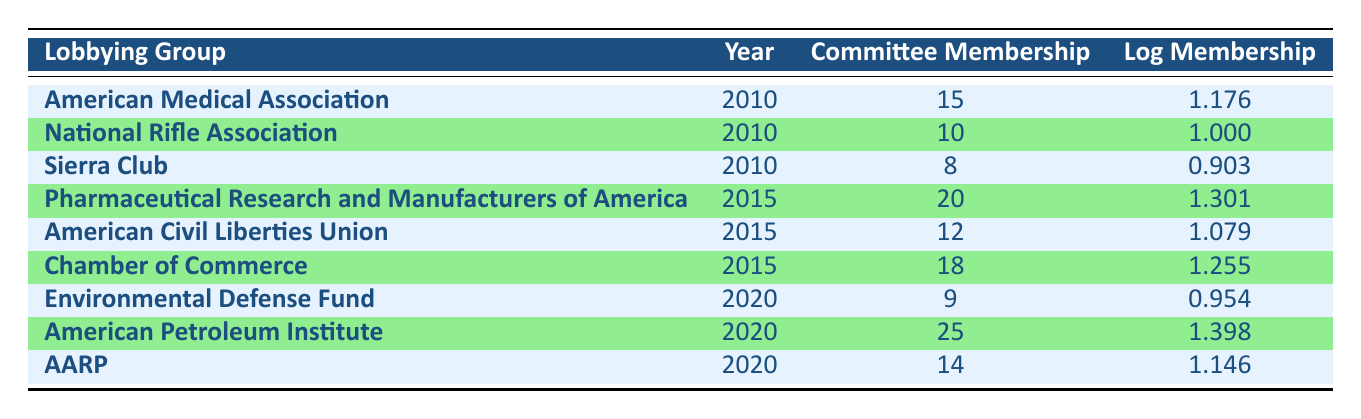What was the committee membership for the American Medical Association in 2010? The table shows that the American Medical Association had a committee membership of 15 in 2010, which is specified in the row corresponding to that organization and year.
Answer: 15 What is the log membership value for the National Rifle Association in 2010? According to the table, the log membership value for the National Rifle Association in 2010 is 1.000, as indicated in the relevant row.
Answer: 1.000 Which lobbying group had the highest committee membership in 2020? Looking at the table for the year 2020, the American Petroleum Institute had the highest committee membership at 25, compared to the other organizations listed for that year.
Answer: American Petroleum Institute Is the log membership value for the Chamber of Commerce in 2015 greater than 1.2? The log membership value for the Chamber of Commerce in 2015 is 1.255, which is indeed greater than 1.2. This can be confirmed by examining the specific data in the table.
Answer: Yes What is the total committee membership for all lobbying groups in 2015? To find the total committee membership for 2015, add the values: 20 (Pharmaceutical Research), 12 (ACLU), and 18 (Chamber of Commerce). Summing these gives 20 + 12 + 18 = 50.
Answer: 50 What was the average log membership value for the lobbying groups in 2010? To calculate the average log membership for 2010, sum the log values: 1.176 (AMA) + 1.000 (NRA) + 0.903 (Sierra Club) = 3.079. There are three groups for 2010, so the average is 3.079 / 3 = 1.026.
Answer: 1.026 Did the representation of the Environmental Defense Fund increase or decrease from 2015 to 2020? The Environmental Defense Fund was not represented in 2015, as it is only listed in 2020 with a committee membership of 9. Thus, its representation did not increase; rather, it simply exists for 2020.
Answer: Decrease Which years did the AARP have a committee membership, and what was their log membership in 2020? The AARP is listed only for the year 2020 in the table with a committee membership value of 14 and a log membership of 1.146.
Answer: 2020, 1.146 How many lobbying groups had a log membership of less than 1 in 2010? According to the table, only the Sierra Club had a log membership of less than 1 in 2010 (0.903), while the others had values above that threshold. Thus, only one group fits this criterion.
Answer: 1 